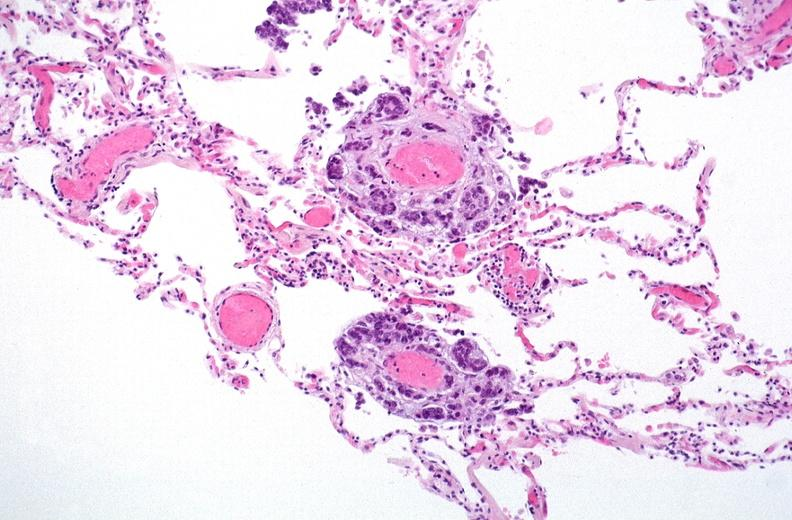does this image show breast cancer metastasis to lung?
Answer the question using a single word or phrase. Yes 